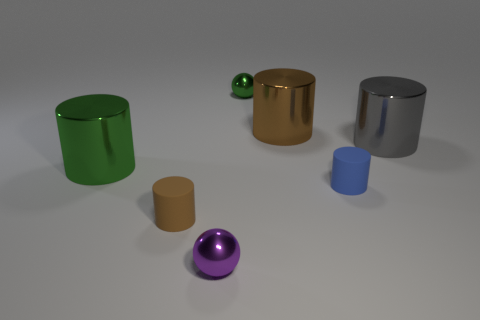There is a shiny thing that is both behind the tiny purple ball and in front of the gray metal thing; what color is it?
Your answer should be very brief. Green. How many objects are small brown cylinders or brown metal cylinders?
Your answer should be compact. 2. How many big objects are blue shiny cubes or brown cylinders?
Your answer should be compact. 1. There is a cylinder that is to the left of the tiny purple metal object and behind the blue rubber cylinder; what size is it?
Your answer should be compact. Large. Is the color of the large metal cylinder that is behind the big gray cylinder the same as the metallic thing in front of the blue cylinder?
Provide a short and direct response. No. What number of other things are the same material as the green cylinder?
Offer a terse response. 4. There is a metal thing that is on the right side of the small green ball and on the left side of the blue thing; what is its shape?
Make the answer very short. Cylinder. Does the green object in front of the gray thing have the same size as the small purple shiny object?
Ensure brevity in your answer.  No. What is the material of the other small object that is the same shape as the tiny green thing?
Provide a short and direct response. Metal. Does the tiny blue object have the same shape as the gray object?
Give a very brief answer. Yes. 